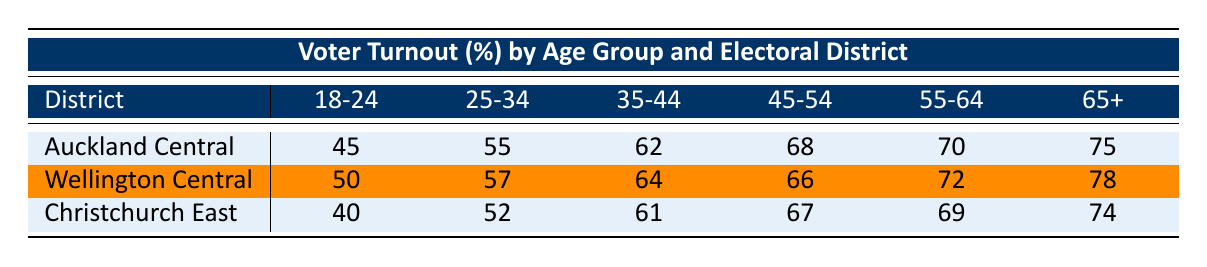What is the voter turnout percentage for the age group 25-34 in Auckland Central? The table shows that the voter turnout percentage for the age group 25-34 in Auckland Central is listed directly, which is 55%.
Answer: 55% In which electoral district did the age group 18-24 have the highest voter turnout percentage? By comparing the turnout percentages for the age group 18-24 in each district, Auckland Central has 45%, Wellington Central has 50%, and Christchurch East has 40%. The highest is in Wellington Central with 50%.
Answer: Wellington Central What is the average voter turnout percentage for the age group 45-54 across all electoral districts? The turnout percentages for the age group 45-54 are 68% for Auckland Central, 66% for Wellington Central, and 67% for Christchurch East. Adding these percentages gives 68 + 66 + 67 = 201, and dividing by the number of districts (3) yields an average of 201/3 = 67%.
Answer: 67% Is the voter turnout percentage for the age group 65+ in Christchurch East greater than that in Auckland Central? The turnout percentage for the age group 65+ in Christchurch East is 74%, while in Auckland Central it is 75%. Since 74% is less than 75%, the statement is false.
Answer: No What is the difference in voter turnout percentage for the age group 55-64 between Wellington Central and Christchurch East? The percentages for the age group 55-64 are 72% for Wellington Central and 69% for Christchurch East. The difference is calculated as 72 - 69 = 3%.
Answer: 3% Which age group has the lowest voter turnout percentage in Christchurch East? In Christchurch East, the lowest voter turnout percentage is for the age group 18-24 at 40%, which can be identified by comparing all age group percentages in that district.
Answer: 40% What is the total voter turnout percentage when you sum the percentages of the 65+ age group across all three districts? The turnout percentages for the 65+ age group are 75% for Auckland Central, 78% for Wellington Central, and 74% for Christchurch East. The total is calculated as 75 + 78 + 74 = 227%.
Answer: 227% Which electoral district has the highest turnout percentage for the age group 35-44? By examining the turnout percentages for the age group 35-44, Auckland Central has 62%, Wellington Central has 64%, and Christchurch East has 61%. Wellington Central has the highest at 64%.
Answer: Wellington Central 